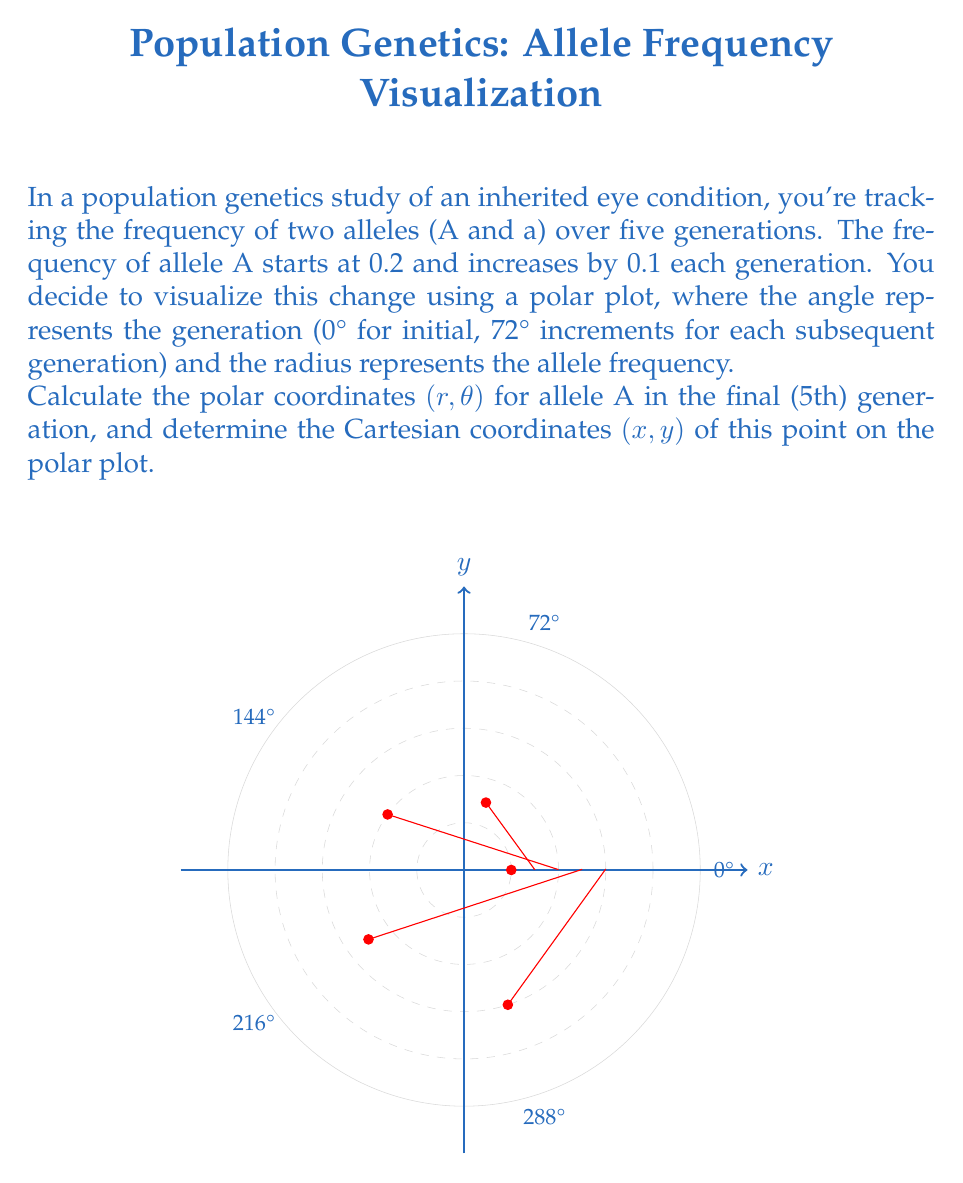Can you solve this math problem? Let's approach this step-by-step:

1) First, we need to determine the polar coordinates $(r, \theta)$ for the 5th generation:

   $r$ (radius) = Allele frequency
   Initial frequency = 0.2
   Increase per generation = 0.1
   Number of generations = 5
   
   So, $r = 0.2 + (5-1) * 0.1 = 0.2 + 0.4 = 0.6$

   $\theta$ (angle) = 72° * (generation number - 1)
   For 5th generation: $\theta = 72° * 4 = 288°$

   Therefore, the polar coordinates are $(0.6, 288°)$

2) To convert polar coordinates $(r, \theta)$ to Cartesian coordinates $(x, y)$, we use these formulas:

   $x = r \cos(\theta)$
   $y = r \sin(\theta)$

3) We need to convert the angle to radians:
   $288° = 288 * \frac{\pi}{180} = \frac{8\pi}{5}$ radians

4) Now we can calculate $x$ and $y$:

   $x = 0.6 \cos(\frac{8\pi}{5})$
   $y = 0.6 \sin(\frac{8\pi}{5})$

5) Using a calculator or computer:

   $x \approx 0.1876$
   $y \approx -0.5711$

Thus, the Cartesian coordinates are approximately (0.1876, -0.5711).
Answer: Polar: $(0.6, 288°)$, Cartesian: $(0.1876, -0.5711)$ 